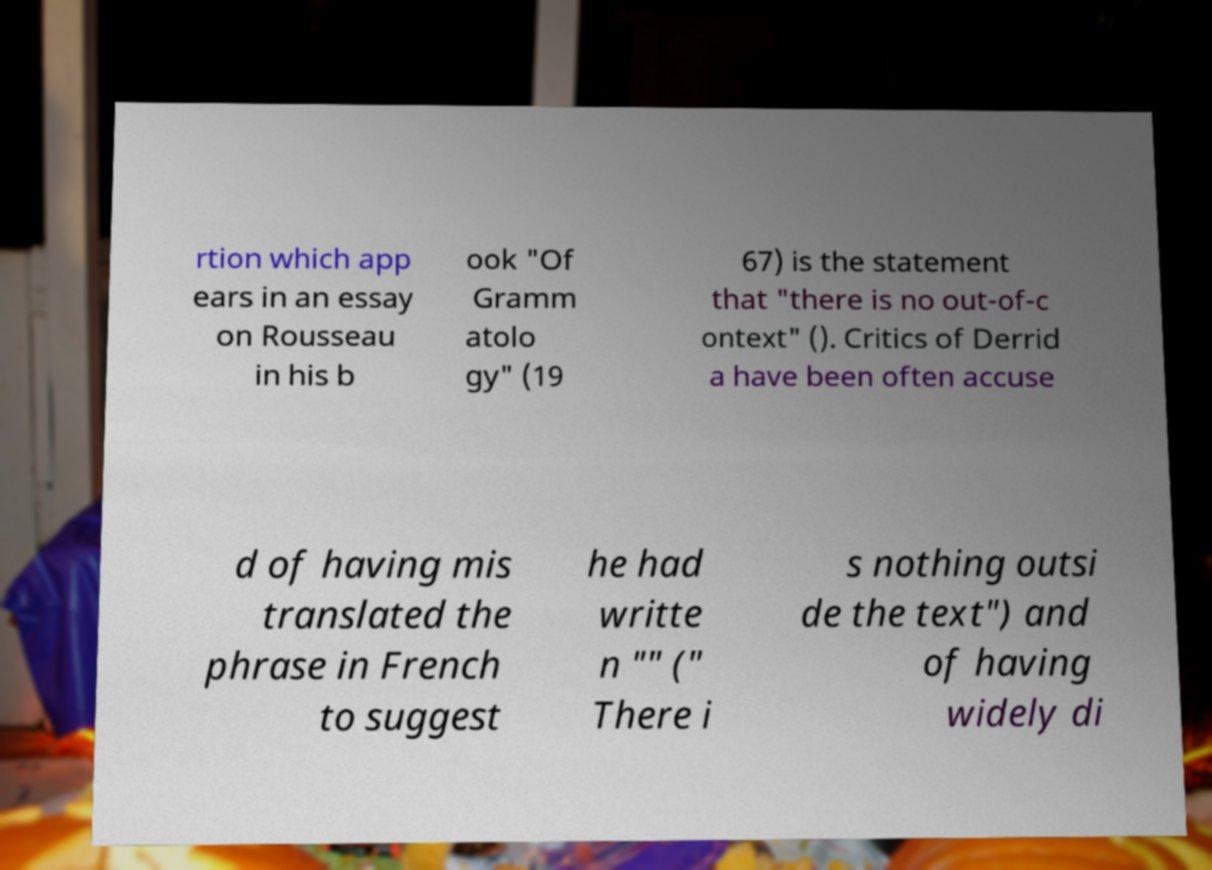Please identify and transcribe the text found in this image. rtion which app ears in an essay on Rousseau in his b ook "Of Gramm atolo gy" (19 67) is the statement that "there is no out-of-c ontext" (). Critics of Derrid a have been often accuse d of having mis translated the phrase in French to suggest he had writte n "" (" There i s nothing outsi de the text") and of having widely di 